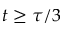<formula> <loc_0><loc_0><loc_500><loc_500>t \geq \tau / 3</formula> 